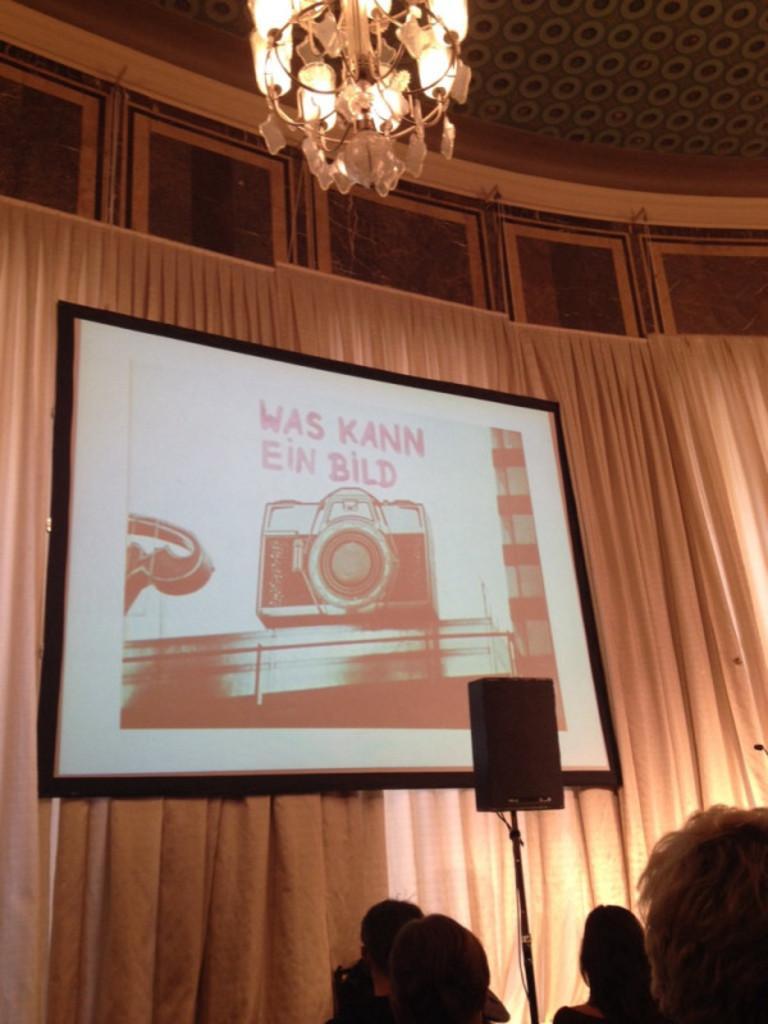Can you describe this image briefly? At the bottom of the image there are people. In the background of the image there are curtains. There is a screen. At the top of the image there is ceiling. There is a light. 